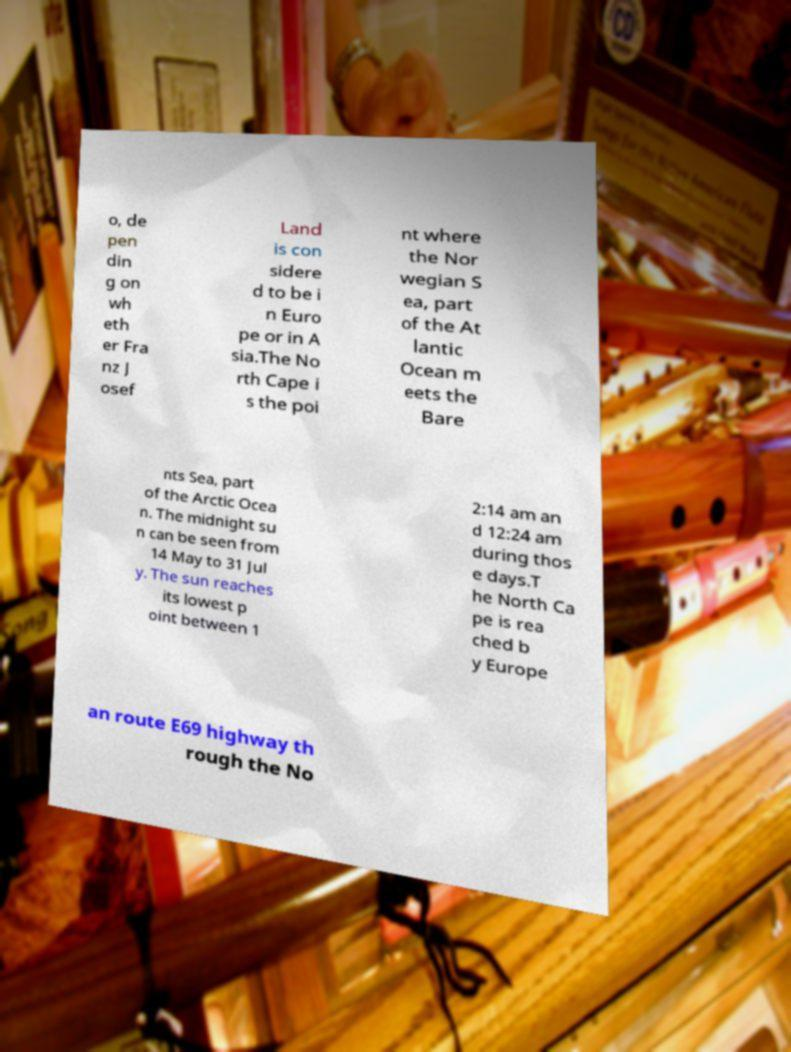For documentation purposes, I need the text within this image transcribed. Could you provide that? o, de pen din g on wh eth er Fra nz J osef Land is con sidere d to be i n Euro pe or in A sia.The No rth Cape i s the poi nt where the Nor wegian S ea, part of the At lantic Ocean m eets the Bare nts Sea, part of the Arctic Ocea n. The midnight su n can be seen from 14 May to 31 Jul y. The sun reaches its lowest p oint between 1 2:14 am an d 12:24 am during thos e days.T he North Ca pe is rea ched b y Europe an route E69 highway th rough the No 